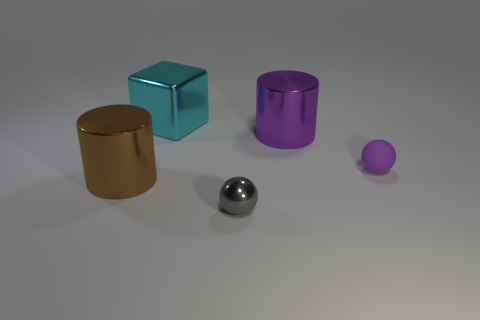Subtract all red balls. Subtract all green cylinders. How many balls are left? 2 Subtract all gray blocks. How many cyan balls are left? 0 Add 4 things. How many small grays exist? 0 Subtract all large purple cylinders. Subtract all purple matte objects. How many objects are left? 3 Add 5 shiny objects. How many shiny objects are left? 9 Add 1 small rubber spheres. How many small rubber spheres exist? 2 Add 4 purple rubber objects. How many objects exist? 9 Subtract all purple balls. How many balls are left? 1 Subtract 0 blue balls. How many objects are left? 5 Subtract all spheres. How many objects are left? 3 